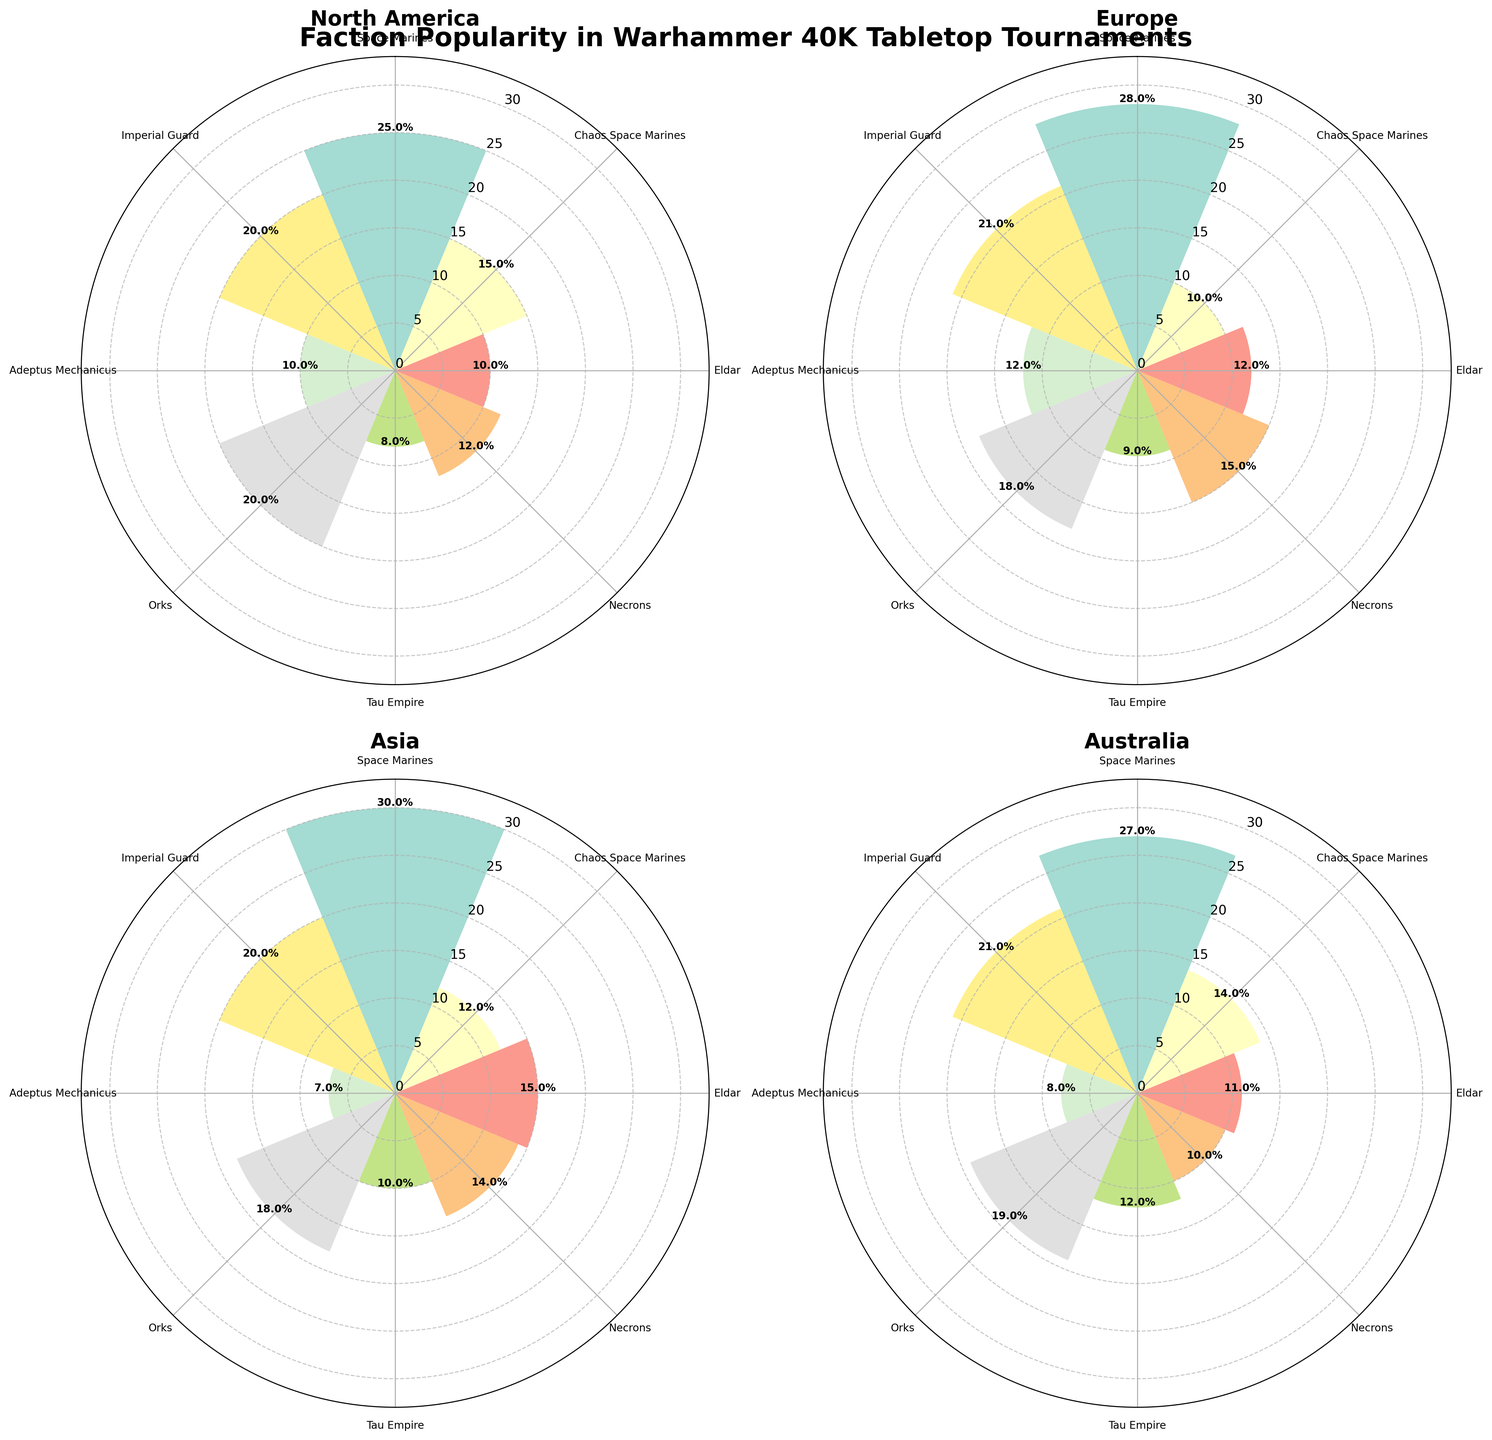Which region has the highest popularity for Space Marines? The plot shows the Space Marines bar with the highest radii in the Asian region subplot, indicating the highest popularity.
Answer: Asia Which faction is the least popular in North America? In the North America subplot, the faction with the smallest radii is the Tau Empire.
Answer: Tau Empire How does the popularity of Orks compare between Europe and Australia? Refer to the subplots for Europe and Australia. The Orks bar in Europe has a radii of 18, while in Australia, the Orks bar has a radii of 19. Thus, Orks are slightly more popular in Australia.
Answer: More popular in Australia What is the sum of popularities for the Chaos Space Marines faction across all regions? Sum the popularity values for Chaos Space Marines in all subplots: 15 (NA) + 10 (EU) + 12 (Asia) + 14 (Australia) = 51.
Answer: 51 Which region has the most balanced distribution of faction popularity? Balance would be indicated by similar heights of all bars. Examine all subplots to see that Australia's bars are more evenly distributed compared to other regions.
Answer: Australia Which faction has the highest total popularity across all regions? Sum the popularity values for each faction: 
- Space Marines: 25 + 28 + 30 + 27 = 110
- Chaos Space Marines: 15 + 10 + 12 + 14 = 51
- Eldar: 10 + 12 + 15 + 11 = 48
- Necrons: 12 + 15 + 14 + 10 = 51
- Tau Empire: 8 + 9 + 10 + 12 = 39
- Orks: 20 + 18 + 18 + 19 = 75
- Adeptus Mechanicus: 10 + 12 + 7 + 8 = 37
- Imperial Guard: 20 + 21 + 20 + 21 = 82
Space Marines have the highest total popularity.
Answer: Space Marines What is the average popularity of the Eldar faction across different regions? Sum of Eldar popularity values: 10 (NA) + 12 (EU) + 15 (Asia) + 11 (Australia) = 48. Divide by the number of regions, 48 / 4 = 12.
Answer: 12 Are there any regions where Space Marines are not the most popular faction? Examine each subplot to see that Space Marines have the highest radii in all regions. Hence, in every region, they are the most popular.
Answer: No How many factions have a popularity of 20 or greater in North America? In the North America subplot, factions with a popularity of 20 or more: Space Marines (25), Orks (20), Imperial Guard (20). Count them to get 3.
Answer: 3 